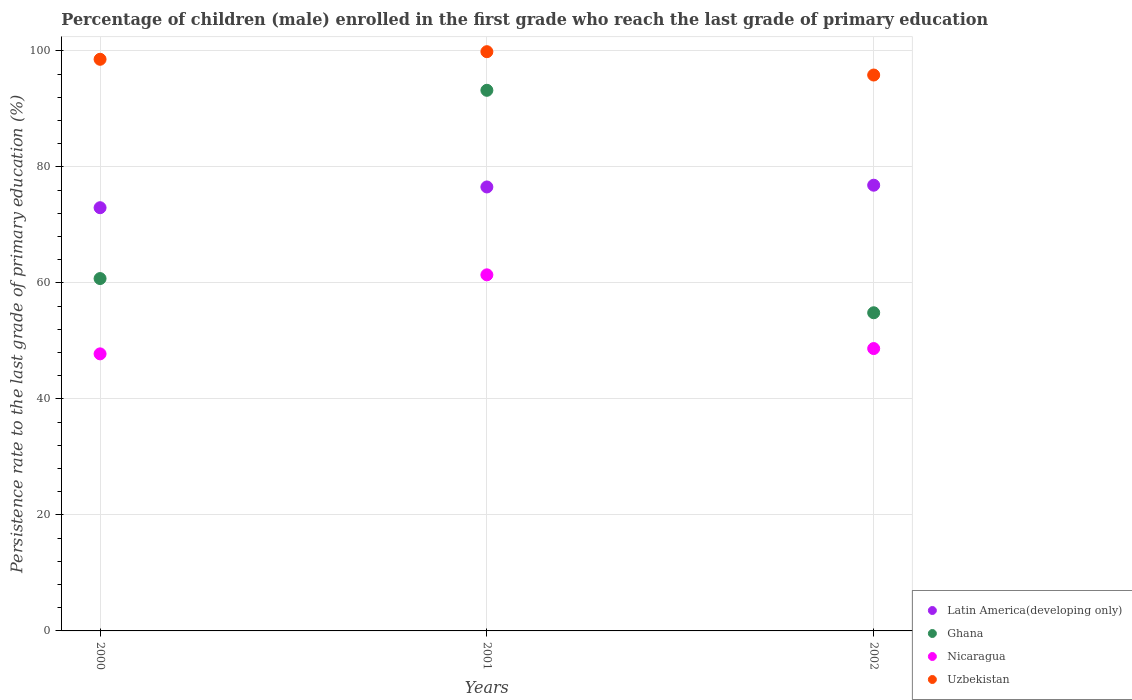Is the number of dotlines equal to the number of legend labels?
Your answer should be compact. Yes. What is the persistence rate of children in Latin America(developing only) in 2001?
Make the answer very short. 76.54. Across all years, what is the maximum persistence rate of children in Nicaragua?
Keep it short and to the point. 61.39. Across all years, what is the minimum persistence rate of children in Ghana?
Provide a succinct answer. 54.85. In which year was the persistence rate of children in Latin America(developing only) minimum?
Offer a very short reply. 2000. What is the total persistence rate of children in Ghana in the graph?
Your response must be concise. 208.8. What is the difference between the persistence rate of children in Ghana in 2000 and that in 2002?
Your response must be concise. 5.9. What is the difference between the persistence rate of children in Uzbekistan in 2002 and the persistence rate of children in Ghana in 2001?
Your response must be concise. 2.63. What is the average persistence rate of children in Uzbekistan per year?
Offer a very short reply. 98.08. In the year 2000, what is the difference between the persistence rate of children in Nicaragua and persistence rate of children in Ghana?
Give a very brief answer. -12.98. In how many years, is the persistence rate of children in Latin America(developing only) greater than 84 %?
Ensure brevity in your answer.  0. What is the ratio of the persistence rate of children in Ghana in 2000 to that in 2001?
Your answer should be compact. 0.65. What is the difference between the highest and the second highest persistence rate of children in Ghana?
Your response must be concise. 32.46. What is the difference between the highest and the lowest persistence rate of children in Nicaragua?
Offer a terse response. 13.62. Is the persistence rate of children in Uzbekistan strictly less than the persistence rate of children in Nicaragua over the years?
Give a very brief answer. No. How many dotlines are there?
Make the answer very short. 4. Are the values on the major ticks of Y-axis written in scientific E-notation?
Your response must be concise. No. Does the graph contain grids?
Keep it short and to the point. Yes. How many legend labels are there?
Offer a very short reply. 4. What is the title of the graph?
Offer a terse response. Percentage of children (male) enrolled in the first grade who reach the last grade of primary education. Does "Nepal" appear as one of the legend labels in the graph?
Make the answer very short. No. What is the label or title of the Y-axis?
Keep it short and to the point. Persistence rate to the last grade of primary education (%). What is the Persistence rate to the last grade of primary education (%) in Latin America(developing only) in 2000?
Your answer should be very brief. 72.96. What is the Persistence rate to the last grade of primary education (%) in Ghana in 2000?
Offer a very short reply. 60.75. What is the Persistence rate to the last grade of primary education (%) in Nicaragua in 2000?
Your answer should be compact. 47.77. What is the Persistence rate to the last grade of primary education (%) in Uzbekistan in 2000?
Ensure brevity in your answer.  98.55. What is the Persistence rate to the last grade of primary education (%) of Latin America(developing only) in 2001?
Offer a very short reply. 76.54. What is the Persistence rate to the last grade of primary education (%) of Ghana in 2001?
Make the answer very short. 93.2. What is the Persistence rate to the last grade of primary education (%) in Nicaragua in 2001?
Your response must be concise. 61.39. What is the Persistence rate to the last grade of primary education (%) in Uzbekistan in 2001?
Your answer should be compact. 99.86. What is the Persistence rate to the last grade of primary education (%) in Latin America(developing only) in 2002?
Your answer should be very brief. 76.84. What is the Persistence rate to the last grade of primary education (%) of Ghana in 2002?
Your answer should be very brief. 54.85. What is the Persistence rate to the last grade of primary education (%) of Nicaragua in 2002?
Your answer should be compact. 48.68. What is the Persistence rate to the last grade of primary education (%) of Uzbekistan in 2002?
Give a very brief answer. 95.84. Across all years, what is the maximum Persistence rate to the last grade of primary education (%) in Latin America(developing only)?
Provide a short and direct response. 76.84. Across all years, what is the maximum Persistence rate to the last grade of primary education (%) of Ghana?
Keep it short and to the point. 93.2. Across all years, what is the maximum Persistence rate to the last grade of primary education (%) of Nicaragua?
Ensure brevity in your answer.  61.39. Across all years, what is the maximum Persistence rate to the last grade of primary education (%) of Uzbekistan?
Give a very brief answer. 99.86. Across all years, what is the minimum Persistence rate to the last grade of primary education (%) of Latin America(developing only)?
Provide a succinct answer. 72.96. Across all years, what is the minimum Persistence rate to the last grade of primary education (%) in Ghana?
Make the answer very short. 54.85. Across all years, what is the minimum Persistence rate to the last grade of primary education (%) in Nicaragua?
Offer a terse response. 47.77. Across all years, what is the minimum Persistence rate to the last grade of primary education (%) of Uzbekistan?
Offer a very short reply. 95.84. What is the total Persistence rate to the last grade of primary education (%) in Latin America(developing only) in the graph?
Offer a terse response. 226.35. What is the total Persistence rate to the last grade of primary education (%) of Ghana in the graph?
Your answer should be very brief. 208.8. What is the total Persistence rate to the last grade of primary education (%) in Nicaragua in the graph?
Give a very brief answer. 157.84. What is the total Persistence rate to the last grade of primary education (%) of Uzbekistan in the graph?
Give a very brief answer. 294.25. What is the difference between the Persistence rate to the last grade of primary education (%) in Latin America(developing only) in 2000 and that in 2001?
Ensure brevity in your answer.  -3.58. What is the difference between the Persistence rate to the last grade of primary education (%) of Ghana in 2000 and that in 2001?
Offer a terse response. -32.46. What is the difference between the Persistence rate to the last grade of primary education (%) of Nicaragua in 2000 and that in 2001?
Offer a very short reply. -13.62. What is the difference between the Persistence rate to the last grade of primary education (%) in Uzbekistan in 2000 and that in 2001?
Give a very brief answer. -1.31. What is the difference between the Persistence rate to the last grade of primary education (%) in Latin America(developing only) in 2000 and that in 2002?
Keep it short and to the point. -3.88. What is the difference between the Persistence rate to the last grade of primary education (%) of Ghana in 2000 and that in 2002?
Provide a succinct answer. 5.9. What is the difference between the Persistence rate to the last grade of primary education (%) of Nicaragua in 2000 and that in 2002?
Your answer should be compact. -0.91. What is the difference between the Persistence rate to the last grade of primary education (%) in Uzbekistan in 2000 and that in 2002?
Your answer should be very brief. 2.71. What is the difference between the Persistence rate to the last grade of primary education (%) of Latin America(developing only) in 2001 and that in 2002?
Give a very brief answer. -0.3. What is the difference between the Persistence rate to the last grade of primary education (%) of Ghana in 2001 and that in 2002?
Provide a short and direct response. 38.35. What is the difference between the Persistence rate to the last grade of primary education (%) in Nicaragua in 2001 and that in 2002?
Offer a terse response. 12.71. What is the difference between the Persistence rate to the last grade of primary education (%) of Uzbekistan in 2001 and that in 2002?
Your answer should be very brief. 4.02. What is the difference between the Persistence rate to the last grade of primary education (%) of Latin America(developing only) in 2000 and the Persistence rate to the last grade of primary education (%) of Ghana in 2001?
Provide a short and direct response. -20.24. What is the difference between the Persistence rate to the last grade of primary education (%) of Latin America(developing only) in 2000 and the Persistence rate to the last grade of primary education (%) of Nicaragua in 2001?
Your answer should be very brief. 11.57. What is the difference between the Persistence rate to the last grade of primary education (%) of Latin America(developing only) in 2000 and the Persistence rate to the last grade of primary education (%) of Uzbekistan in 2001?
Offer a very short reply. -26.9. What is the difference between the Persistence rate to the last grade of primary education (%) in Ghana in 2000 and the Persistence rate to the last grade of primary education (%) in Nicaragua in 2001?
Your answer should be very brief. -0.64. What is the difference between the Persistence rate to the last grade of primary education (%) of Ghana in 2000 and the Persistence rate to the last grade of primary education (%) of Uzbekistan in 2001?
Your answer should be compact. -39.11. What is the difference between the Persistence rate to the last grade of primary education (%) in Nicaragua in 2000 and the Persistence rate to the last grade of primary education (%) in Uzbekistan in 2001?
Your answer should be compact. -52.1. What is the difference between the Persistence rate to the last grade of primary education (%) of Latin America(developing only) in 2000 and the Persistence rate to the last grade of primary education (%) of Ghana in 2002?
Your response must be concise. 18.11. What is the difference between the Persistence rate to the last grade of primary education (%) of Latin America(developing only) in 2000 and the Persistence rate to the last grade of primary education (%) of Nicaragua in 2002?
Provide a short and direct response. 24.28. What is the difference between the Persistence rate to the last grade of primary education (%) in Latin America(developing only) in 2000 and the Persistence rate to the last grade of primary education (%) in Uzbekistan in 2002?
Offer a very short reply. -22.87. What is the difference between the Persistence rate to the last grade of primary education (%) in Ghana in 2000 and the Persistence rate to the last grade of primary education (%) in Nicaragua in 2002?
Provide a short and direct response. 12.07. What is the difference between the Persistence rate to the last grade of primary education (%) of Ghana in 2000 and the Persistence rate to the last grade of primary education (%) of Uzbekistan in 2002?
Make the answer very short. -35.09. What is the difference between the Persistence rate to the last grade of primary education (%) of Nicaragua in 2000 and the Persistence rate to the last grade of primary education (%) of Uzbekistan in 2002?
Keep it short and to the point. -48.07. What is the difference between the Persistence rate to the last grade of primary education (%) in Latin America(developing only) in 2001 and the Persistence rate to the last grade of primary education (%) in Ghana in 2002?
Your answer should be compact. 21.69. What is the difference between the Persistence rate to the last grade of primary education (%) in Latin America(developing only) in 2001 and the Persistence rate to the last grade of primary education (%) in Nicaragua in 2002?
Offer a terse response. 27.86. What is the difference between the Persistence rate to the last grade of primary education (%) in Latin America(developing only) in 2001 and the Persistence rate to the last grade of primary education (%) in Uzbekistan in 2002?
Your response must be concise. -19.3. What is the difference between the Persistence rate to the last grade of primary education (%) in Ghana in 2001 and the Persistence rate to the last grade of primary education (%) in Nicaragua in 2002?
Ensure brevity in your answer.  44.52. What is the difference between the Persistence rate to the last grade of primary education (%) of Ghana in 2001 and the Persistence rate to the last grade of primary education (%) of Uzbekistan in 2002?
Provide a succinct answer. -2.63. What is the difference between the Persistence rate to the last grade of primary education (%) in Nicaragua in 2001 and the Persistence rate to the last grade of primary education (%) in Uzbekistan in 2002?
Your response must be concise. -34.45. What is the average Persistence rate to the last grade of primary education (%) of Latin America(developing only) per year?
Provide a short and direct response. 75.45. What is the average Persistence rate to the last grade of primary education (%) of Ghana per year?
Offer a terse response. 69.6. What is the average Persistence rate to the last grade of primary education (%) of Nicaragua per year?
Your response must be concise. 52.61. What is the average Persistence rate to the last grade of primary education (%) of Uzbekistan per year?
Provide a succinct answer. 98.08. In the year 2000, what is the difference between the Persistence rate to the last grade of primary education (%) in Latin America(developing only) and Persistence rate to the last grade of primary education (%) in Ghana?
Provide a short and direct response. 12.22. In the year 2000, what is the difference between the Persistence rate to the last grade of primary education (%) of Latin America(developing only) and Persistence rate to the last grade of primary education (%) of Nicaragua?
Offer a terse response. 25.2. In the year 2000, what is the difference between the Persistence rate to the last grade of primary education (%) of Latin America(developing only) and Persistence rate to the last grade of primary education (%) of Uzbekistan?
Provide a short and direct response. -25.59. In the year 2000, what is the difference between the Persistence rate to the last grade of primary education (%) of Ghana and Persistence rate to the last grade of primary education (%) of Nicaragua?
Provide a short and direct response. 12.98. In the year 2000, what is the difference between the Persistence rate to the last grade of primary education (%) in Ghana and Persistence rate to the last grade of primary education (%) in Uzbekistan?
Ensure brevity in your answer.  -37.8. In the year 2000, what is the difference between the Persistence rate to the last grade of primary education (%) in Nicaragua and Persistence rate to the last grade of primary education (%) in Uzbekistan?
Your response must be concise. -50.78. In the year 2001, what is the difference between the Persistence rate to the last grade of primary education (%) of Latin America(developing only) and Persistence rate to the last grade of primary education (%) of Ghana?
Ensure brevity in your answer.  -16.66. In the year 2001, what is the difference between the Persistence rate to the last grade of primary education (%) in Latin America(developing only) and Persistence rate to the last grade of primary education (%) in Nicaragua?
Offer a very short reply. 15.15. In the year 2001, what is the difference between the Persistence rate to the last grade of primary education (%) in Latin America(developing only) and Persistence rate to the last grade of primary education (%) in Uzbekistan?
Your answer should be very brief. -23.32. In the year 2001, what is the difference between the Persistence rate to the last grade of primary education (%) in Ghana and Persistence rate to the last grade of primary education (%) in Nicaragua?
Your answer should be very brief. 31.81. In the year 2001, what is the difference between the Persistence rate to the last grade of primary education (%) in Ghana and Persistence rate to the last grade of primary education (%) in Uzbekistan?
Your answer should be very brief. -6.66. In the year 2001, what is the difference between the Persistence rate to the last grade of primary education (%) of Nicaragua and Persistence rate to the last grade of primary education (%) of Uzbekistan?
Offer a very short reply. -38.47. In the year 2002, what is the difference between the Persistence rate to the last grade of primary education (%) of Latin America(developing only) and Persistence rate to the last grade of primary education (%) of Ghana?
Offer a terse response. 21.99. In the year 2002, what is the difference between the Persistence rate to the last grade of primary education (%) in Latin America(developing only) and Persistence rate to the last grade of primary education (%) in Nicaragua?
Provide a short and direct response. 28.16. In the year 2002, what is the difference between the Persistence rate to the last grade of primary education (%) in Latin America(developing only) and Persistence rate to the last grade of primary education (%) in Uzbekistan?
Offer a terse response. -18.99. In the year 2002, what is the difference between the Persistence rate to the last grade of primary education (%) of Ghana and Persistence rate to the last grade of primary education (%) of Nicaragua?
Make the answer very short. 6.17. In the year 2002, what is the difference between the Persistence rate to the last grade of primary education (%) of Ghana and Persistence rate to the last grade of primary education (%) of Uzbekistan?
Make the answer very short. -40.99. In the year 2002, what is the difference between the Persistence rate to the last grade of primary education (%) in Nicaragua and Persistence rate to the last grade of primary education (%) in Uzbekistan?
Your answer should be very brief. -47.16. What is the ratio of the Persistence rate to the last grade of primary education (%) in Latin America(developing only) in 2000 to that in 2001?
Provide a short and direct response. 0.95. What is the ratio of the Persistence rate to the last grade of primary education (%) in Ghana in 2000 to that in 2001?
Keep it short and to the point. 0.65. What is the ratio of the Persistence rate to the last grade of primary education (%) in Nicaragua in 2000 to that in 2001?
Your answer should be very brief. 0.78. What is the ratio of the Persistence rate to the last grade of primary education (%) of Uzbekistan in 2000 to that in 2001?
Your answer should be very brief. 0.99. What is the ratio of the Persistence rate to the last grade of primary education (%) of Latin America(developing only) in 2000 to that in 2002?
Provide a succinct answer. 0.95. What is the ratio of the Persistence rate to the last grade of primary education (%) of Ghana in 2000 to that in 2002?
Offer a terse response. 1.11. What is the ratio of the Persistence rate to the last grade of primary education (%) in Nicaragua in 2000 to that in 2002?
Offer a terse response. 0.98. What is the ratio of the Persistence rate to the last grade of primary education (%) of Uzbekistan in 2000 to that in 2002?
Provide a short and direct response. 1.03. What is the ratio of the Persistence rate to the last grade of primary education (%) of Ghana in 2001 to that in 2002?
Ensure brevity in your answer.  1.7. What is the ratio of the Persistence rate to the last grade of primary education (%) in Nicaragua in 2001 to that in 2002?
Your response must be concise. 1.26. What is the ratio of the Persistence rate to the last grade of primary education (%) of Uzbekistan in 2001 to that in 2002?
Provide a succinct answer. 1.04. What is the difference between the highest and the second highest Persistence rate to the last grade of primary education (%) in Latin America(developing only)?
Keep it short and to the point. 0.3. What is the difference between the highest and the second highest Persistence rate to the last grade of primary education (%) in Ghana?
Keep it short and to the point. 32.46. What is the difference between the highest and the second highest Persistence rate to the last grade of primary education (%) in Nicaragua?
Keep it short and to the point. 12.71. What is the difference between the highest and the second highest Persistence rate to the last grade of primary education (%) of Uzbekistan?
Keep it short and to the point. 1.31. What is the difference between the highest and the lowest Persistence rate to the last grade of primary education (%) in Latin America(developing only)?
Offer a very short reply. 3.88. What is the difference between the highest and the lowest Persistence rate to the last grade of primary education (%) of Ghana?
Your answer should be compact. 38.35. What is the difference between the highest and the lowest Persistence rate to the last grade of primary education (%) of Nicaragua?
Provide a short and direct response. 13.62. What is the difference between the highest and the lowest Persistence rate to the last grade of primary education (%) of Uzbekistan?
Ensure brevity in your answer.  4.02. 